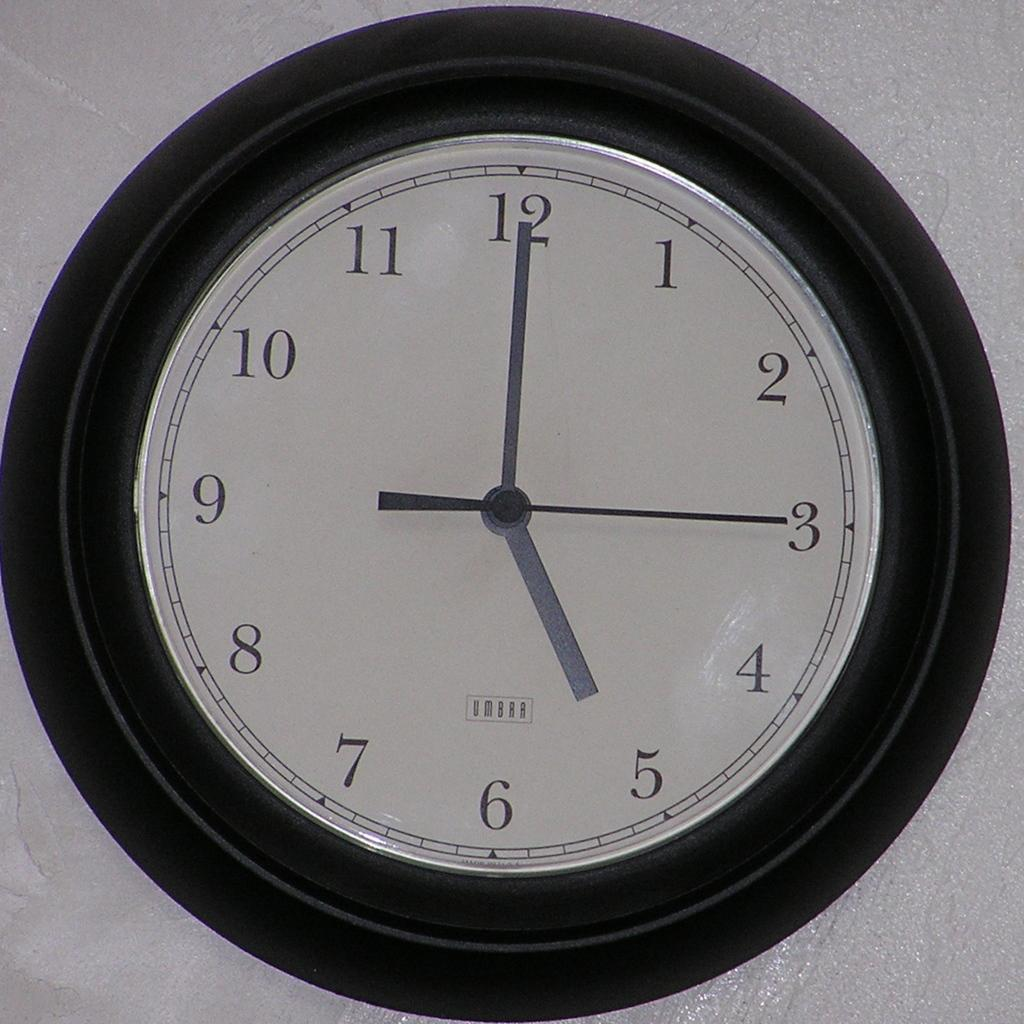<image>
Write a terse but informative summary of the picture. A spartan clock in a heavy black frame sports the Umbra name. 